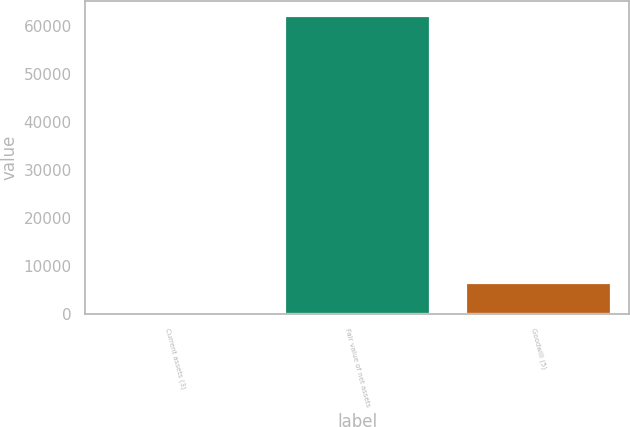Convert chart to OTSL. <chart><loc_0><loc_0><loc_500><loc_500><bar_chart><fcel>Current assets (3)<fcel>Fair value of net assets<fcel>Goodwill (5)<nl><fcel>359<fcel>62104<fcel>6533.5<nl></chart> 